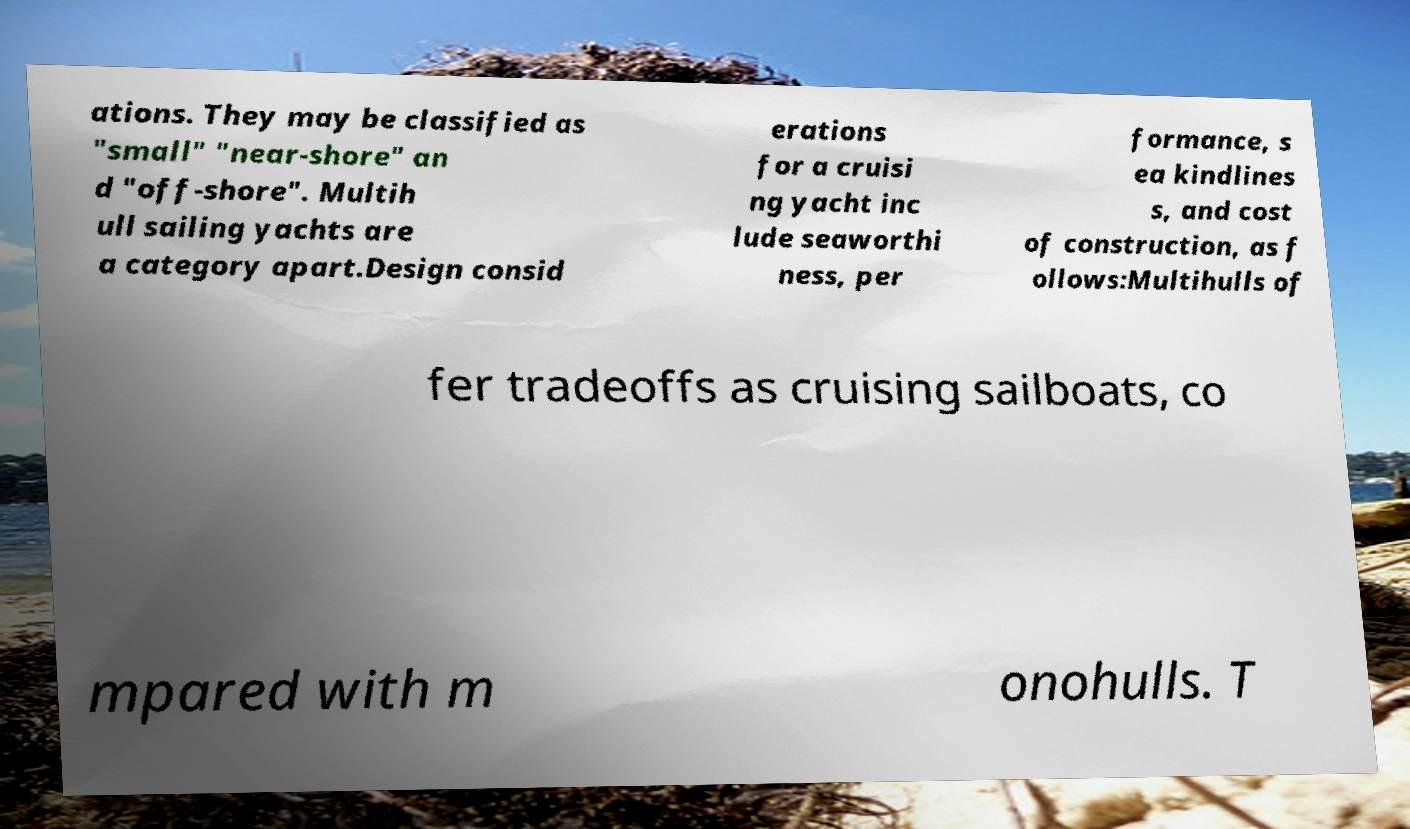Please identify and transcribe the text found in this image. ations. They may be classified as "small" "near-shore" an d "off-shore". Multih ull sailing yachts are a category apart.Design consid erations for a cruisi ng yacht inc lude seaworthi ness, per formance, s ea kindlines s, and cost of construction, as f ollows:Multihulls of fer tradeoffs as cruising sailboats, co mpared with m onohulls. T 